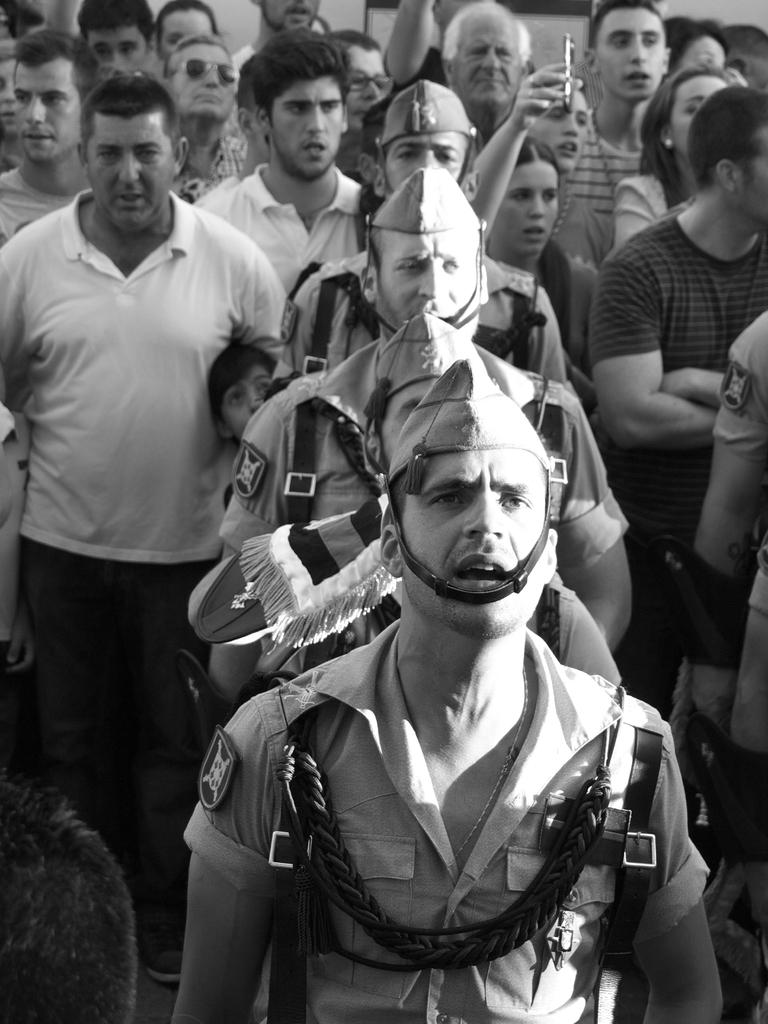What is the color scheme of the image? The image is black and white. What can be seen in terms of people in the image? There is a group of people standing in the image. Is there any person holding an object in the image? Yes, there is a person holding an object in the image. What type of pest can be seen crawling on the boundary in the image? There is no pest or boundary present in the image; it features a group of people and a person holding an object. 